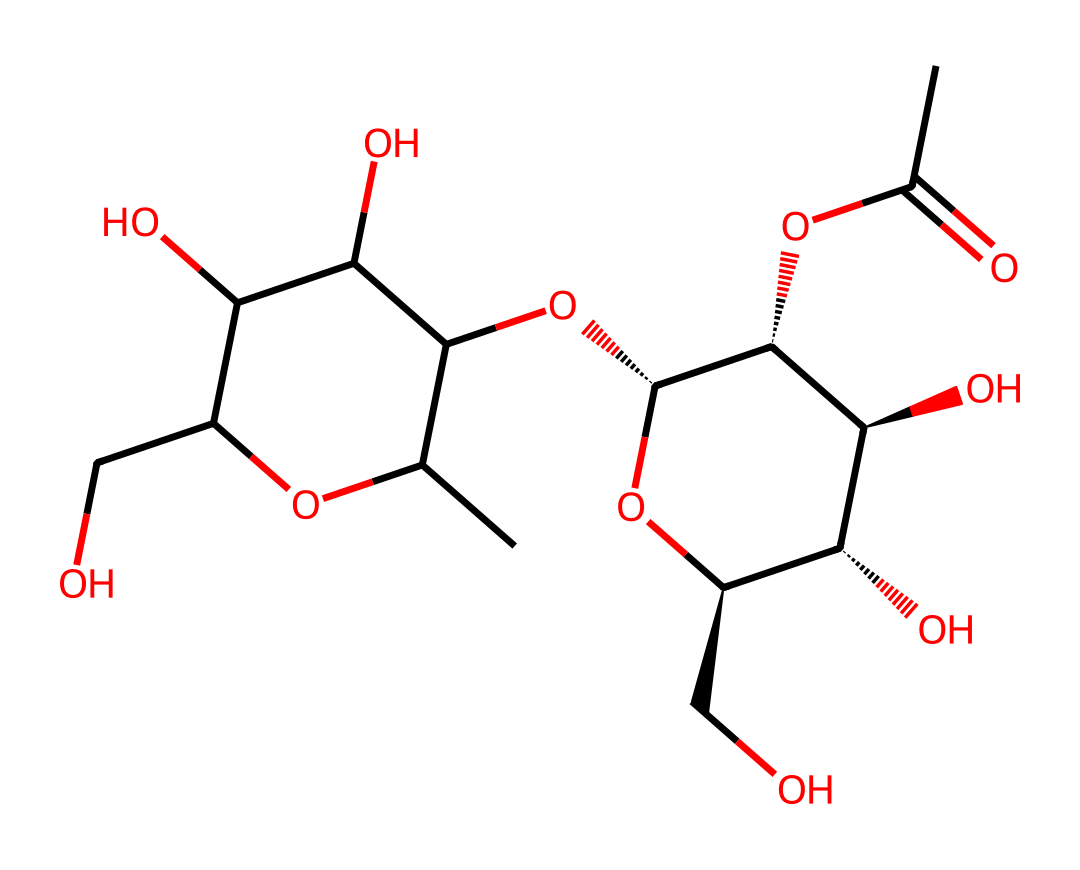What is the main functional group present in this chemical? The chemical structure contains multiple hydroxyl (–OH) groups, which are characteristic of carbohydrates. By identifying the -OH groups throughout the molecule, we can conclude that this is indeed a carbohydrate with significant hydroxyl functionality.
Answer: hydroxyl How many carbon atoms are in this chemical? By counting the carbon atoms in the provided SMILES representation, we identify 9 distinct carbon atoms. The structure, upon visualizing or interpreting the SMILES, exhibits these carbon atoms as part of the overall carbohydrate composition.
Answer: 9 Does this chemical contain any rings in its structure? The structure contains a cyclic framework, as indicated by the presence of carbon atoms bonded in a ring formation within the SMILES representation. This can be interpreted by recognizing the signs of branching and cyclic connectivity.
Answer: yes What type of linkage is characterized by the connection in this carbohydrate? This carbohydrate features glycosidic linkages, which are formed between the hydroxyl groups on adjacent sugar units. The presence of these linkages can be reasoned by observing how the hydroxyl groups connect to create oligosaccharides within the cyclic structure.
Answer: glycosidic What is the molecular weight of this compound? To determine the molecular weight, one would sum the atomic weights of all atoms represented in the SMILES notation: carbons, hydrogens, and oxygens. After calculation, the total molecular weight for the compound is approximately 340 grams per mole, as derived from the composition.
Answer: 340 What role does pectin typically play in urban composting? Pectin serves primarily as a stabilizing agent in compost, contributing to the breakdown of organic matter. This is due to its ability to gel and hold moisture, which can be reasoned from its carbohydrate structure, aiding in microbial degradation during composting processes.
Answer: stabilizing agent 